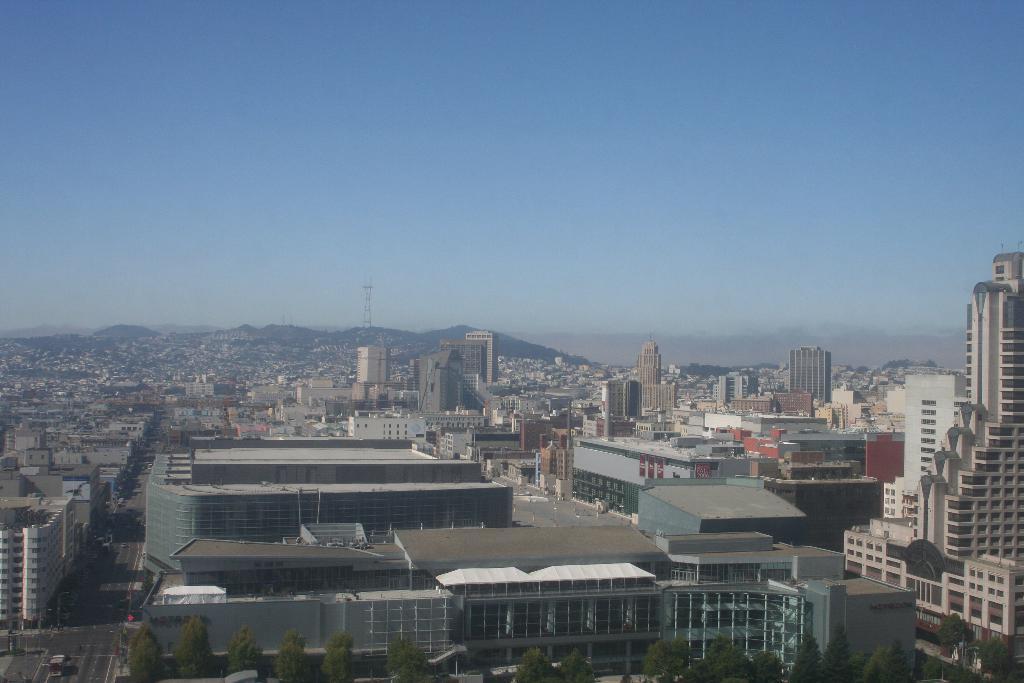How would you summarize this image in a sentence or two? In this picture we can see buildings, at the bottom there are trees, on the left side we can see some vehicles traveling on the road, in the background there is a tower, we can see the sky at the top of the picture. 